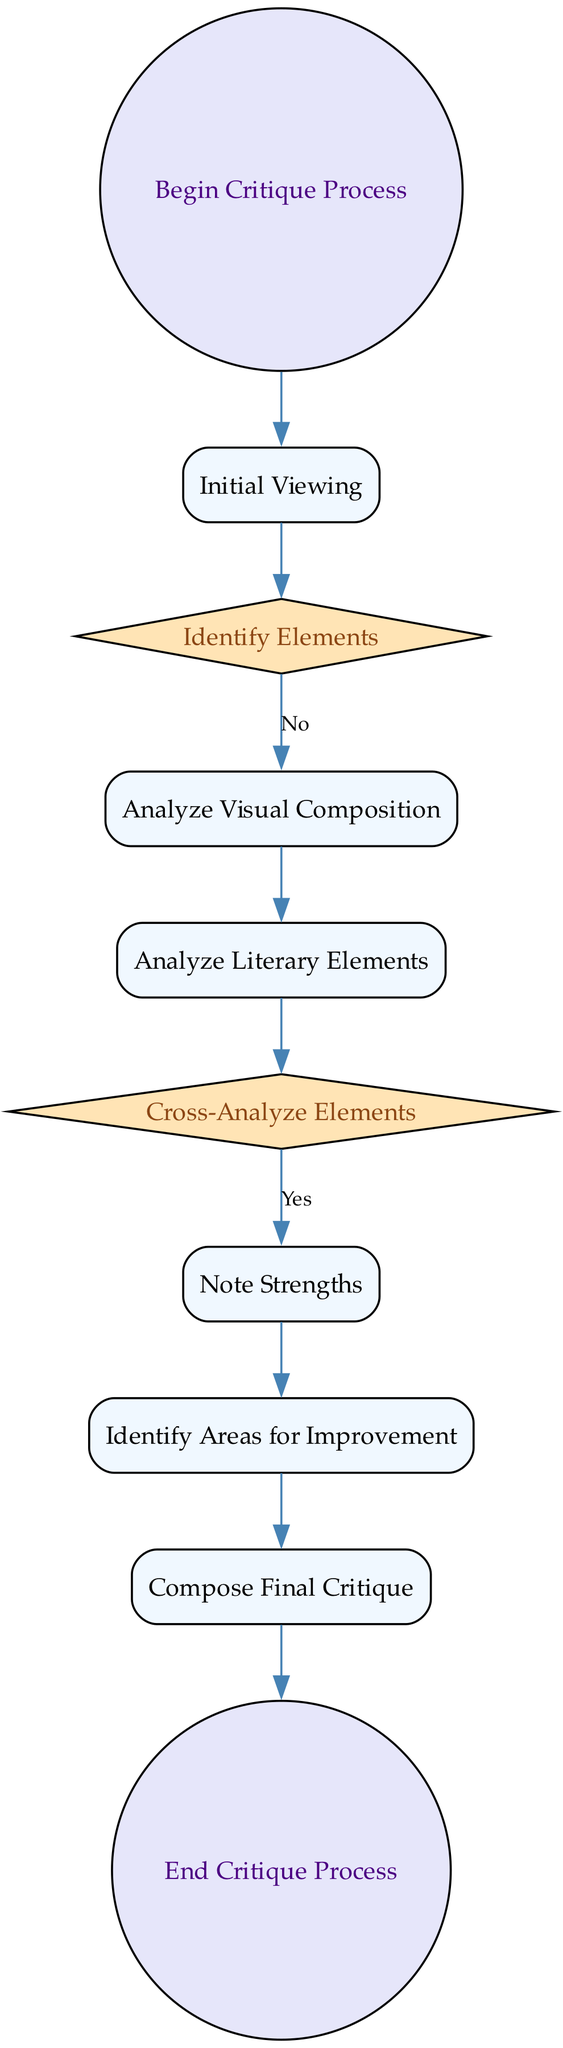What is the first step in the critique process? The diagram starts with the "Begin Critique Process" which initiates the workflow. From there, the next step is "Initial Viewing" of the art piece.
Answer: Begin Critique Process How many decision nodes are present in the diagram? The diagram contains three decision nodes: "Identify Elements," "Cross-Analyze Elements," and each decision has its own distinct role in the workflow, contributing to the overall critique process.
Answer: 3 What activity follows the "Initial Viewing"? After observing the piece as a whole in the "Initial Viewing," the next activity is "Analyze Visual Composition," where specific elements of the artwork are evaluated.
Answer: Analyze Visual Composition Which node signifies the end of the critique process? In this diagram, the "End Critique Process" node indicates the conclusion of the entire workflow, marking the end of the critique process.
Answer: End Critique Process What is the purpose of the "Cross-Analyze Elements" decision? The "Cross-Analyze Elements" decision is crucial for evaluating whether the literary aspects enhance or detract from the visual elements, requiring a deeper look into the interplay between these components.
Answer: Evaluate enhancement or detriment What comes after noting the strengths of the piece? Once the strengths are documented in the "Note Strengths" activity, the critique process moves to "Identify Areas for Improvement," addressing areas that need enhancement.
Answer: Identify Areas for Improvement How does the decision node "Identify Elements" influence the workflow? This decision node determines whether the critic finds a cohesive integration of literary themes; its outcome can direct the flow towards further analysis or backtrack if such integration is lacking.
Answer: Directs further analysis What is the last activity before concluding the critique? The final activity before concluding is "Compose Final Critique," wherein a detailed critique is prepared, noting both strengths and areas for improvement identified earlier in the process.
Answer: Compose Final Critique 